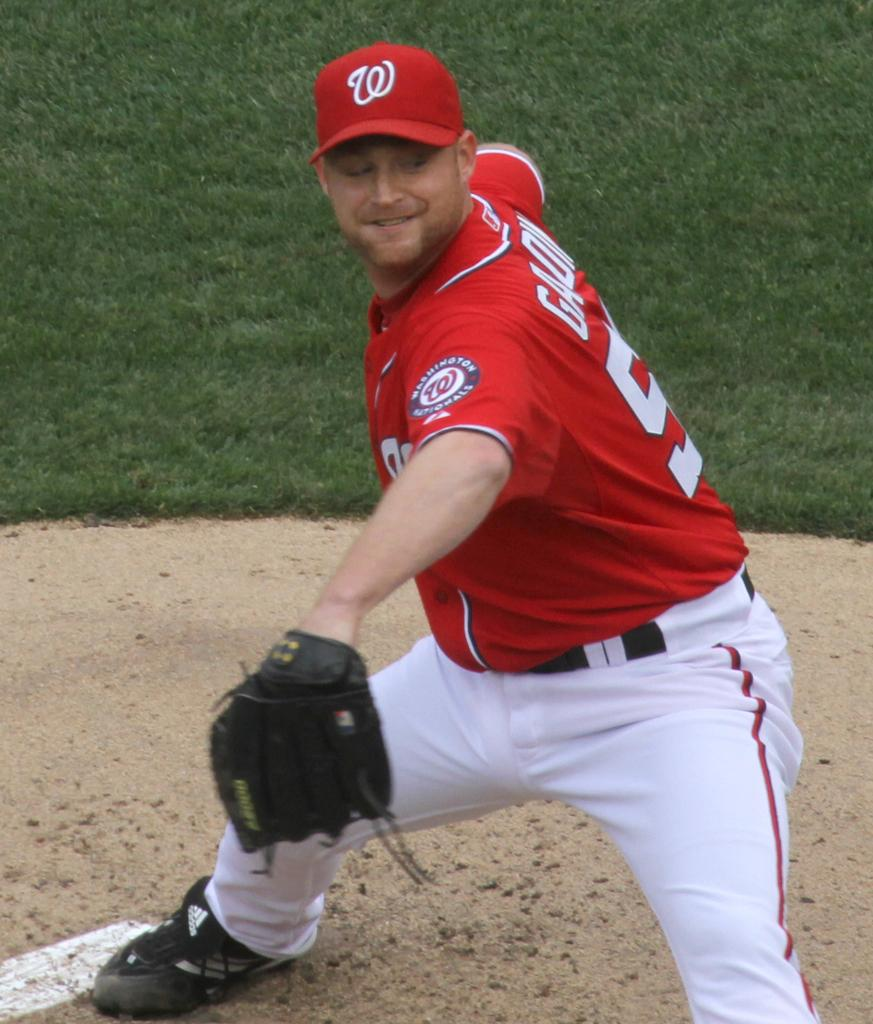<image>
Write a terse but informative summary of the picture. A baseball player that has Washington Nationals written on his sleeve. 